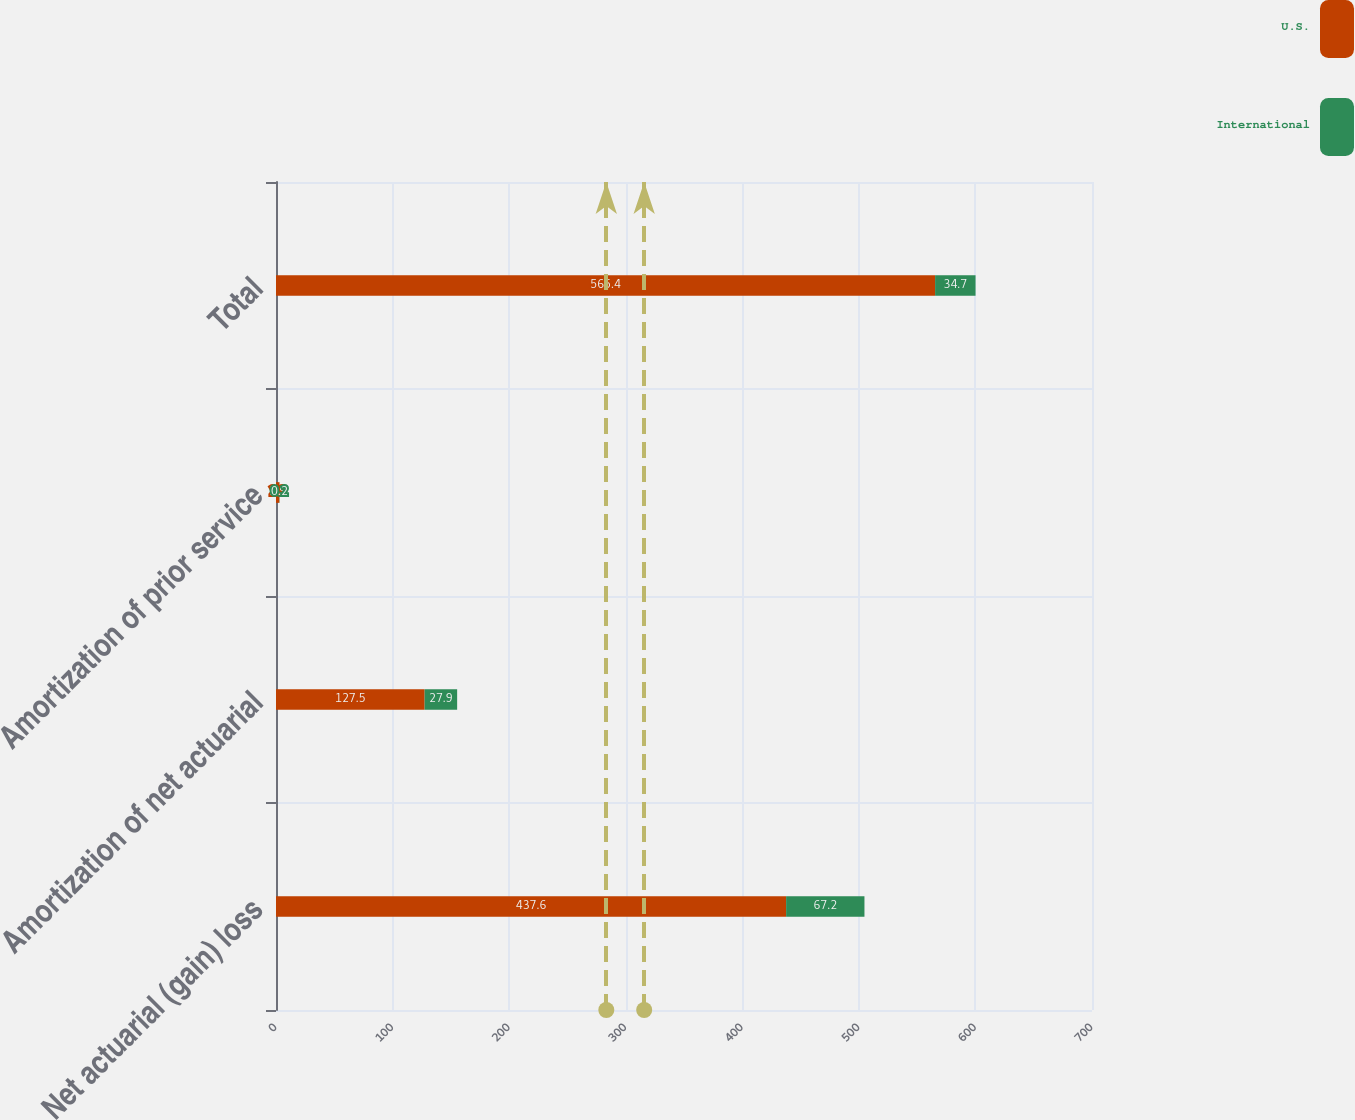Convert chart to OTSL. <chart><loc_0><loc_0><loc_500><loc_500><stacked_bar_chart><ecel><fcel>Net actuarial (gain) loss<fcel>Amortization of net actuarial<fcel>Amortization of prior service<fcel>Total<nl><fcel>U.S.<fcel>437.6<fcel>127.5<fcel>2.9<fcel>565.4<nl><fcel>International<fcel>67.2<fcel>27.9<fcel>0.2<fcel>34.7<nl></chart> 